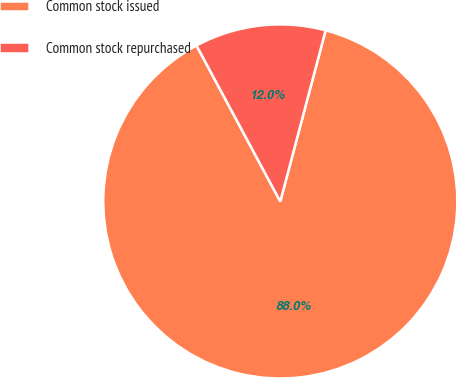Convert chart to OTSL. <chart><loc_0><loc_0><loc_500><loc_500><pie_chart><fcel>Common stock issued<fcel>Common stock repurchased<nl><fcel>88.03%<fcel>11.97%<nl></chart> 